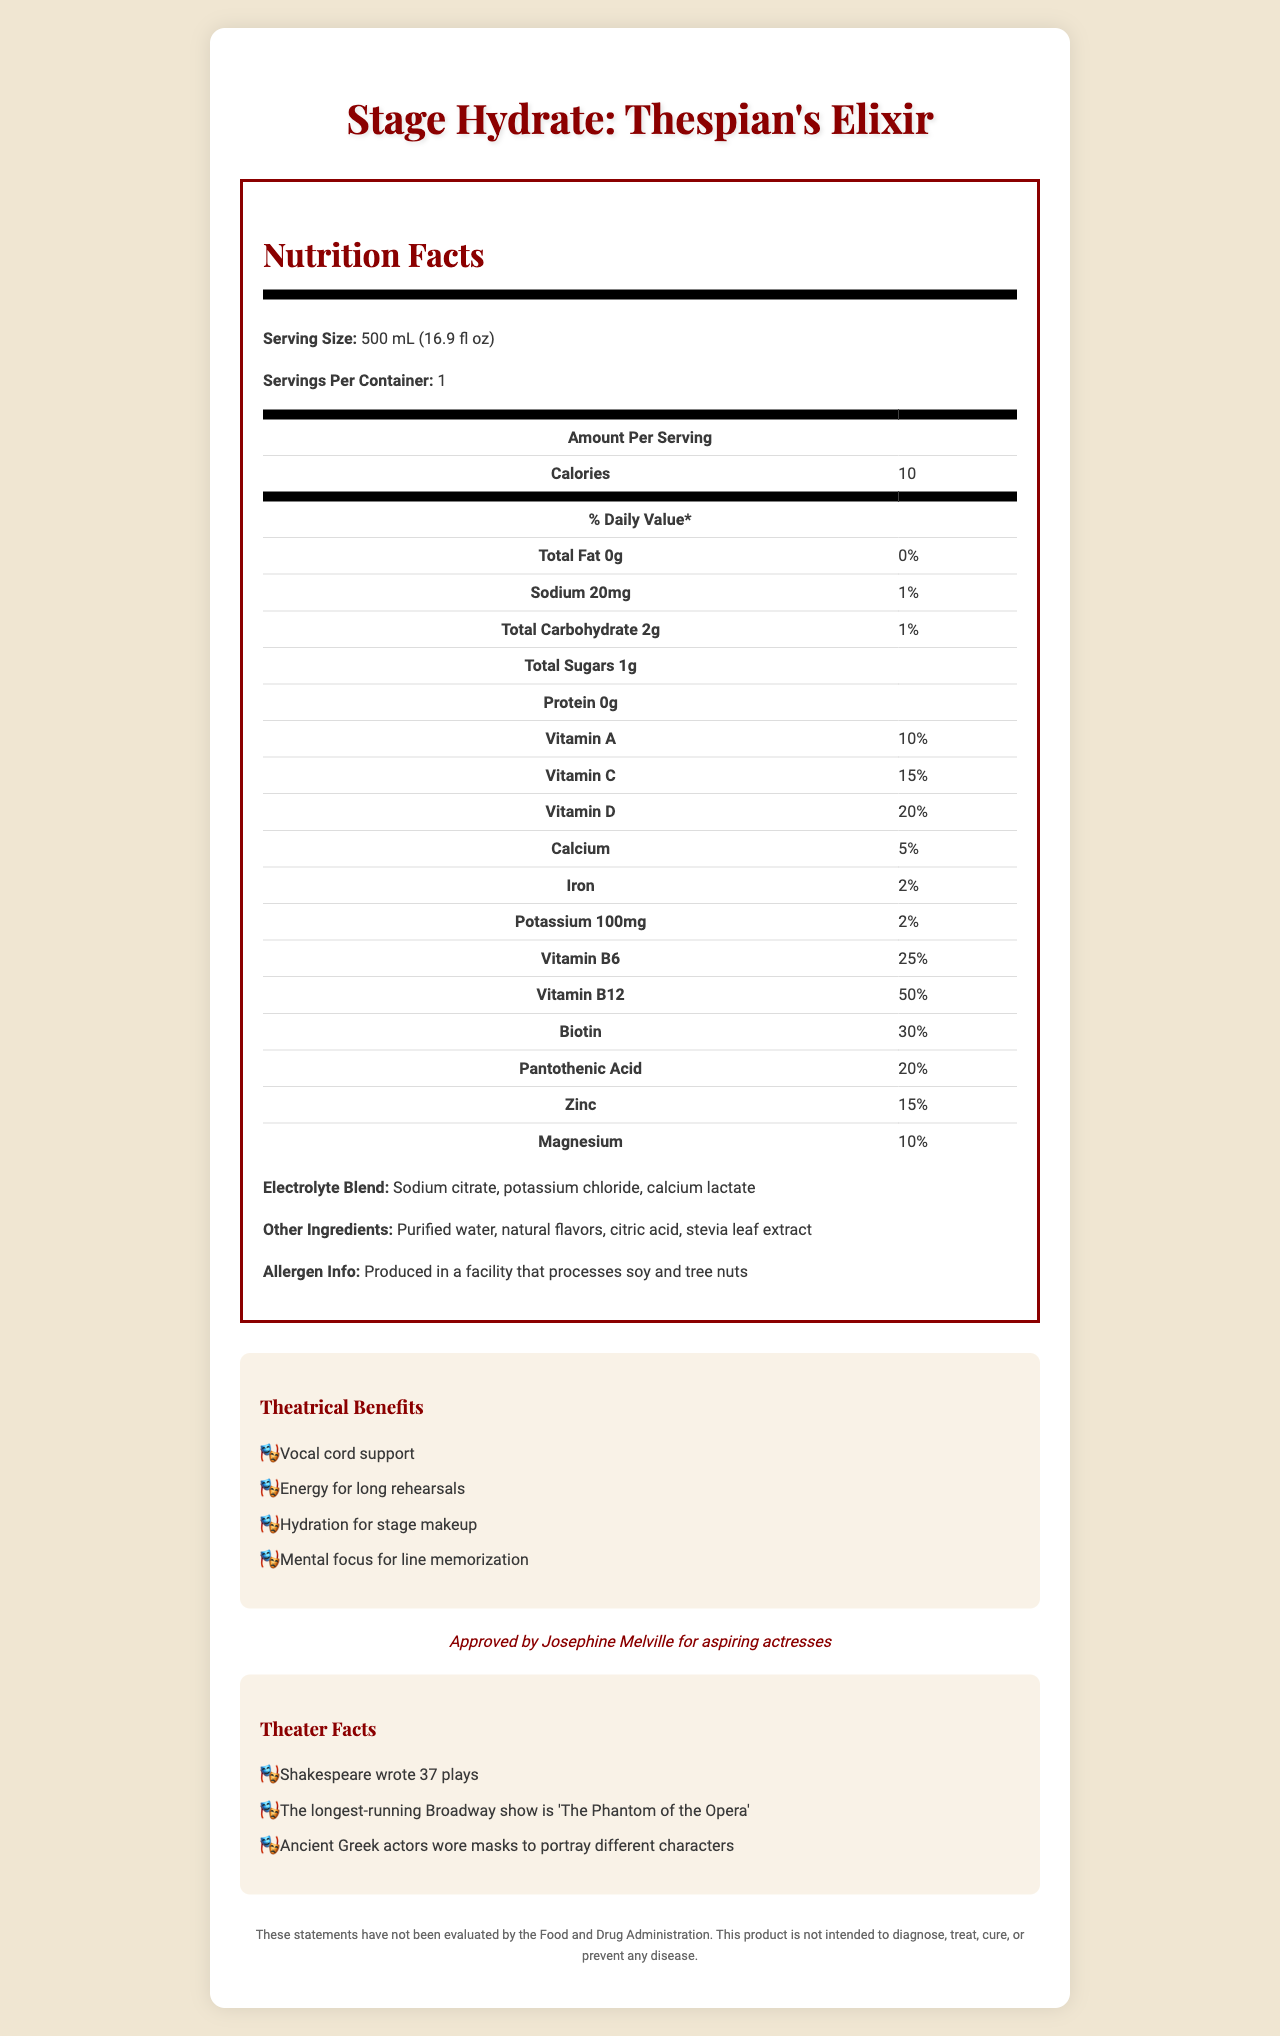what is the serving size of Stage Hydrate: Thespian's Elixir? The serving size is stated at the beginning of the Nutrition Facts section of the document.
Answer: 500 mL (16.9 fl oz) how many calories are in one serving? The document specifies the caloric content as 10 calories per serving.
Answer: 10 list two benefits listed under the theatrical benefits section. The Theatrical Benefits section lists multiple benefits, including "Vocal cord support" and "Energy for long rehearsals".
Answer: Vocal cord support, Energy for long rehearsals what is the percentage of daily value for Vitamin B12? The document lists the daily value for Vitamin B12 as 50%.
Answer: 50% how much sodium is in one serving? The sodium content per serving is specified as 20mg.
Answer: 20mg which ingredient is not part of the electrolyte blend? A. Sodium citrate B. Potassium chloride C. Purified water D. Calcium lactate The document lists Sodium citrate, Potassium chloride, and Calcium lactate as part of the electrolyte blend. Purified water is listed separately under other ingredients.
Answer: C. Purified water which vitamin has the highest daily percentage value in the product? A. Vitamin A B. Vitamin C C. Vitamin B6 D. Vitamin B12 Vitamin B12 has the highest daily value percentage at 50%.
Answer: D. Vitamin B12 is Stage Hydrate: Thespian's Elixir suitable for someone with a soy allergy? The allergen information states that the product is produced in a facility that processes soy, making it potentially unsafe for someone with a soy allergy.
Answer: No how many theater facts are provided in the document? The document lists three theater facts.
Answer: 3 summarize the main idea of the document. The document aims to present the nutritional value and unique benefits of the product, highlighting its suitability for theater professionals with added vitamins and minerals, while also offering engaging information related to the performing arts.
Answer: The document provides detailed nutritional information about Stage Hydrate: Thespian's Elixir, a vitamin-fortified bottled water designed for theater professionals. It outlines the serving size, calorie count, and specific vitamin and mineral content, along with theatrical benefits, celebrity endorsement by Josephine Melville, allergen information, and fun theater facts. what percentage of daily value does Pantothenic Acid contribute? Pantothenic Acid contributes 20% of the daily value, as listed in the document.
Answer: 20% what is the total carbohydrate content? The document specifies that the total carbohydrate content per serving is 2g.
Answer: 2g can you find the contact information for Stage Hydrate in the document? The document does not provide any contact information for Stage Hydrate.
Answer: Cannot be determined 